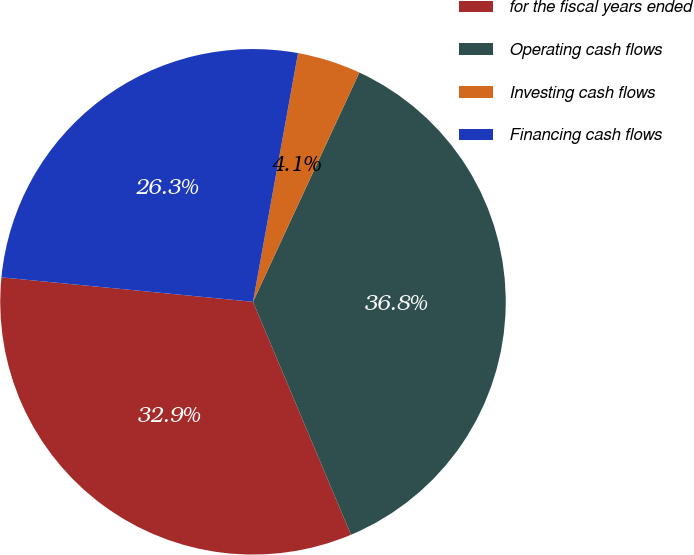Convert chart. <chart><loc_0><loc_0><loc_500><loc_500><pie_chart><fcel>for the fiscal years ended<fcel>Operating cash flows<fcel>Investing cash flows<fcel>Financing cash flows<nl><fcel>32.88%<fcel>36.75%<fcel>4.06%<fcel>26.31%<nl></chart> 